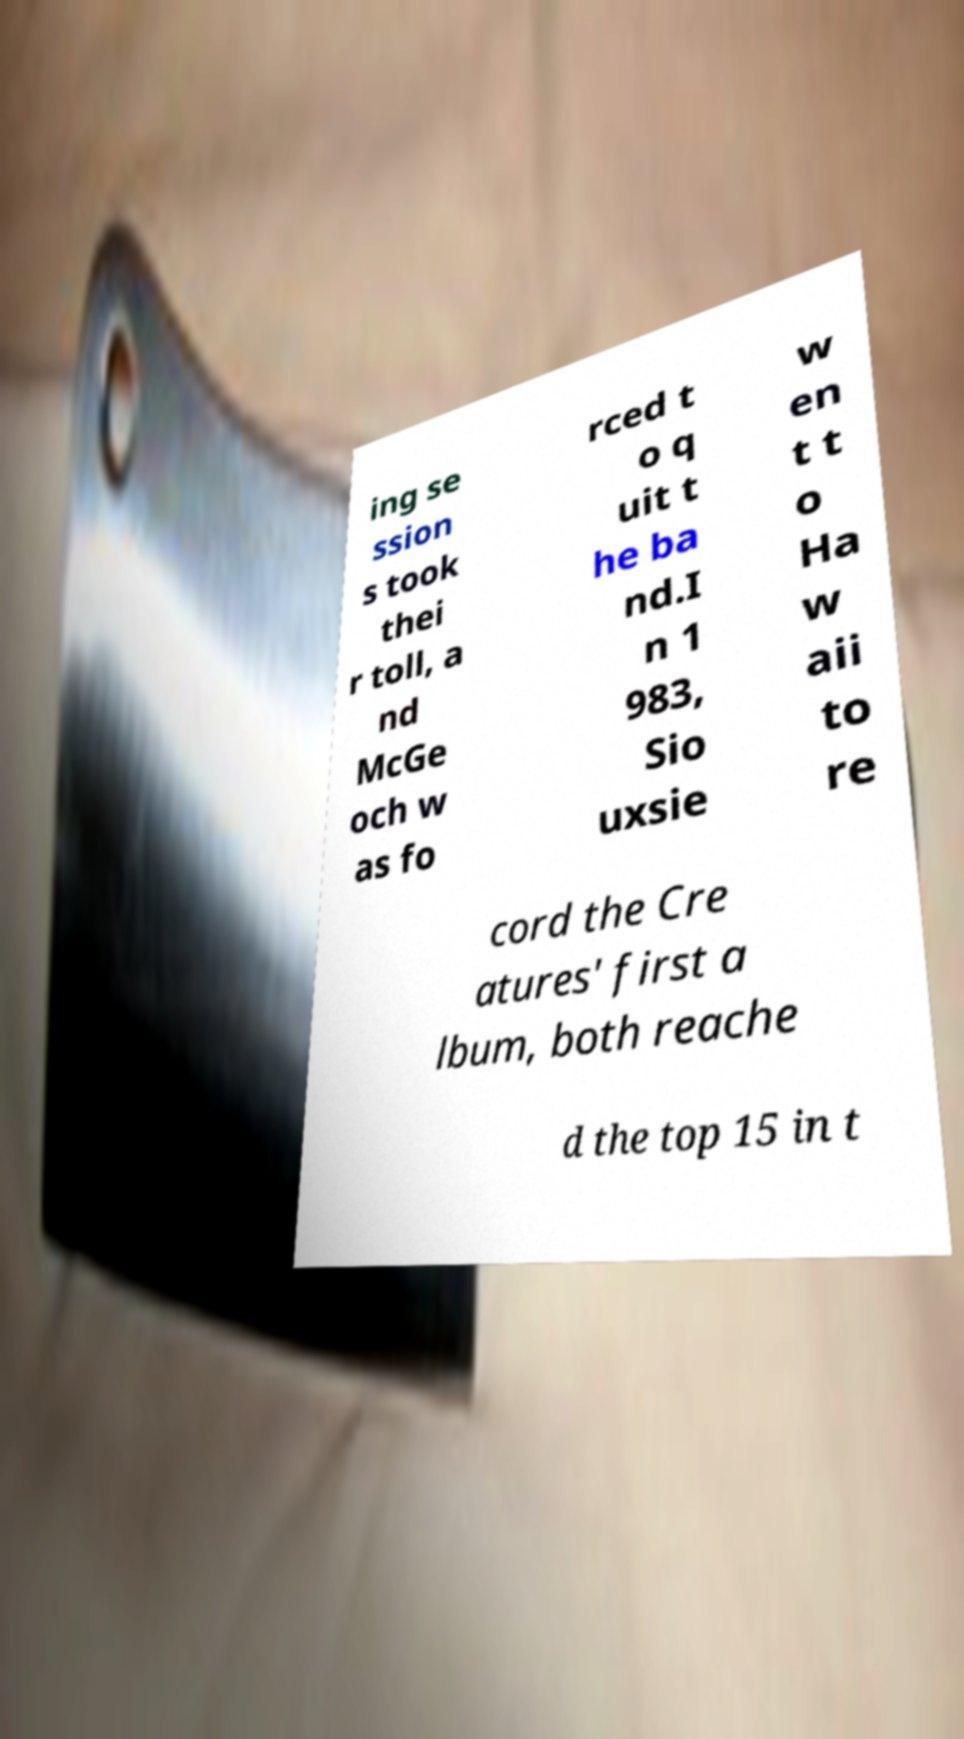Could you assist in decoding the text presented in this image and type it out clearly? ing se ssion s took thei r toll, a nd McGe och w as fo rced t o q uit t he ba nd.I n 1 983, Sio uxsie w en t t o Ha w aii to re cord the Cre atures' first a lbum, both reache d the top 15 in t 